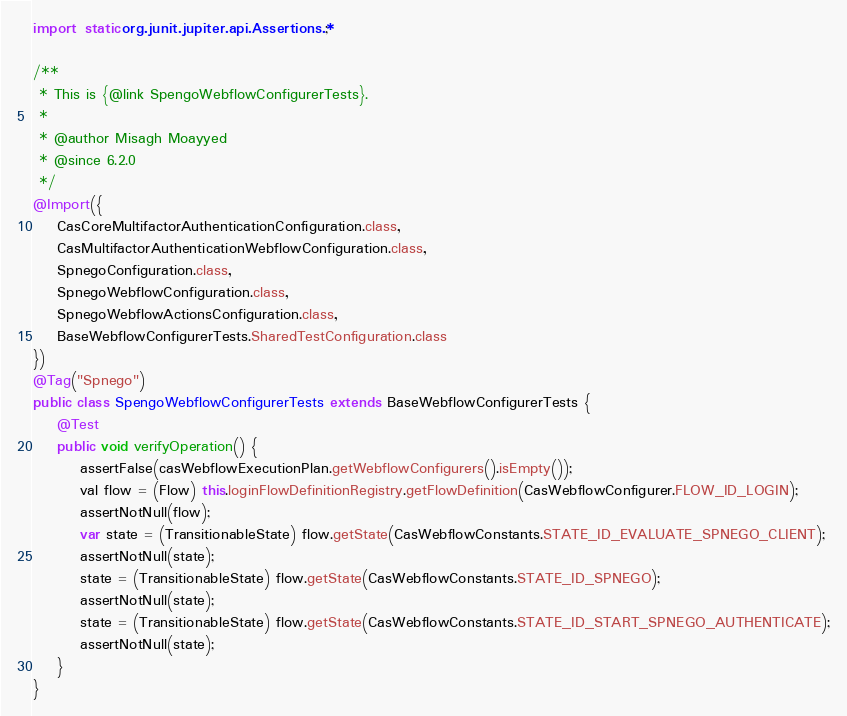Convert code to text. <code><loc_0><loc_0><loc_500><loc_500><_Java_>import static org.junit.jupiter.api.Assertions.*;

/**
 * This is {@link SpengoWebflowConfigurerTests}.
 *
 * @author Misagh Moayyed
 * @since 6.2.0
 */
@Import({
    CasCoreMultifactorAuthenticationConfiguration.class,
    CasMultifactorAuthenticationWebflowConfiguration.class,
    SpnegoConfiguration.class,
    SpnegoWebflowConfiguration.class,
    SpnegoWebflowActionsConfiguration.class,
    BaseWebflowConfigurerTests.SharedTestConfiguration.class
})
@Tag("Spnego")
public class SpengoWebflowConfigurerTests extends BaseWebflowConfigurerTests {
    @Test
    public void verifyOperation() {
        assertFalse(casWebflowExecutionPlan.getWebflowConfigurers().isEmpty());
        val flow = (Flow) this.loginFlowDefinitionRegistry.getFlowDefinition(CasWebflowConfigurer.FLOW_ID_LOGIN);
        assertNotNull(flow);
        var state = (TransitionableState) flow.getState(CasWebflowConstants.STATE_ID_EVALUATE_SPNEGO_CLIENT);
        assertNotNull(state);
        state = (TransitionableState) flow.getState(CasWebflowConstants.STATE_ID_SPNEGO);
        assertNotNull(state);
        state = (TransitionableState) flow.getState(CasWebflowConstants.STATE_ID_START_SPNEGO_AUTHENTICATE);
        assertNotNull(state);
    }
}
</code> 